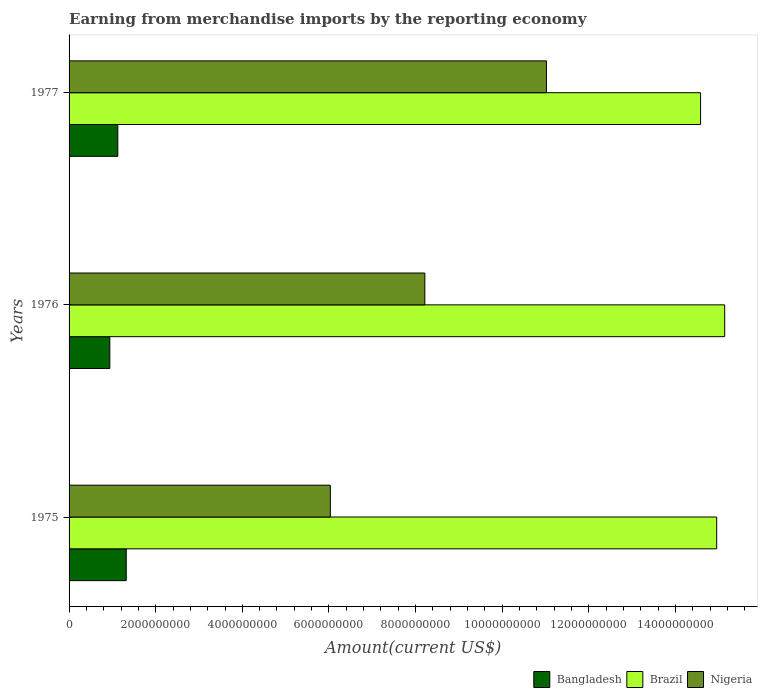How many different coloured bars are there?
Offer a very short reply. 3. Are the number of bars per tick equal to the number of legend labels?
Give a very brief answer. Yes. Are the number of bars on each tick of the Y-axis equal?
Your answer should be very brief. Yes. How many bars are there on the 1st tick from the top?
Keep it short and to the point. 3. How many bars are there on the 1st tick from the bottom?
Your answer should be very brief. 3. What is the label of the 3rd group of bars from the top?
Ensure brevity in your answer.  1975. What is the amount earned from merchandise imports in Brazil in 1977?
Make the answer very short. 1.46e+1. Across all years, what is the maximum amount earned from merchandise imports in Brazil?
Offer a very short reply. 1.51e+1. Across all years, what is the minimum amount earned from merchandise imports in Nigeria?
Offer a very short reply. 6.03e+09. In which year was the amount earned from merchandise imports in Nigeria maximum?
Provide a short and direct response. 1977. In which year was the amount earned from merchandise imports in Nigeria minimum?
Make the answer very short. 1975. What is the total amount earned from merchandise imports in Brazil in the graph?
Offer a very short reply. 4.47e+1. What is the difference between the amount earned from merchandise imports in Bangladesh in 1975 and that in 1977?
Provide a succinct answer. 1.95e+08. What is the difference between the amount earned from merchandise imports in Nigeria in 1975 and the amount earned from merchandise imports in Brazil in 1976?
Offer a very short reply. -9.10e+09. What is the average amount earned from merchandise imports in Brazil per year?
Provide a short and direct response. 1.49e+1. In the year 1977, what is the difference between the amount earned from merchandise imports in Brazil and amount earned from merchandise imports in Bangladesh?
Your response must be concise. 1.35e+1. In how many years, is the amount earned from merchandise imports in Brazil greater than 1600000000 US$?
Give a very brief answer. 3. What is the ratio of the amount earned from merchandise imports in Nigeria in 1975 to that in 1977?
Your response must be concise. 0.55. Is the amount earned from merchandise imports in Bangladesh in 1976 less than that in 1977?
Keep it short and to the point. Yes. What is the difference between the highest and the second highest amount earned from merchandise imports in Nigeria?
Provide a succinct answer. 2.81e+09. What is the difference between the highest and the lowest amount earned from merchandise imports in Nigeria?
Your answer should be compact. 4.99e+09. Is it the case that in every year, the sum of the amount earned from merchandise imports in Nigeria and amount earned from merchandise imports in Bangladesh is greater than the amount earned from merchandise imports in Brazil?
Offer a terse response. No. Are all the bars in the graph horizontal?
Give a very brief answer. Yes. Are the values on the major ticks of X-axis written in scientific E-notation?
Your answer should be compact. No. How many legend labels are there?
Offer a very short reply. 3. What is the title of the graph?
Make the answer very short. Earning from merchandise imports by the reporting economy. What is the label or title of the X-axis?
Keep it short and to the point. Amount(current US$). What is the Amount(current US$) in Bangladesh in 1975?
Give a very brief answer. 1.32e+09. What is the Amount(current US$) in Brazil in 1975?
Provide a succinct answer. 1.50e+1. What is the Amount(current US$) in Nigeria in 1975?
Your answer should be very brief. 6.03e+09. What is the Amount(current US$) in Bangladesh in 1976?
Your answer should be compact. 9.40e+08. What is the Amount(current US$) of Brazil in 1976?
Provide a succinct answer. 1.51e+1. What is the Amount(current US$) of Nigeria in 1976?
Provide a succinct answer. 8.21e+09. What is the Amount(current US$) of Bangladesh in 1977?
Give a very brief answer. 1.12e+09. What is the Amount(current US$) of Brazil in 1977?
Your answer should be very brief. 1.46e+1. What is the Amount(current US$) of Nigeria in 1977?
Ensure brevity in your answer.  1.10e+1. Across all years, what is the maximum Amount(current US$) in Bangladesh?
Provide a short and direct response. 1.32e+09. Across all years, what is the maximum Amount(current US$) of Brazil?
Provide a succinct answer. 1.51e+1. Across all years, what is the maximum Amount(current US$) of Nigeria?
Ensure brevity in your answer.  1.10e+1. Across all years, what is the minimum Amount(current US$) in Bangladesh?
Ensure brevity in your answer.  9.40e+08. Across all years, what is the minimum Amount(current US$) of Brazil?
Provide a short and direct response. 1.46e+1. Across all years, what is the minimum Amount(current US$) of Nigeria?
Provide a succinct answer. 6.03e+09. What is the total Amount(current US$) of Bangladesh in the graph?
Provide a short and direct response. 3.39e+09. What is the total Amount(current US$) of Brazil in the graph?
Your answer should be compact. 4.47e+1. What is the total Amount(current US$) in Nigeria in the graph?
Ensure brevity in your answer.  2.53e+1. What is the difference between the Amount(current US$) in Bangladesh in 1975 and that in 1976?
Your answer should be compact. 3.79e+08. What is the difference between the Amount(current US$) in Brazil in 1975 and that in 1976?
Ensure brevity in your answer.  -1.85e+08. What is the difference between the Amount(current US$) in Nigeria in 1975 and that in 1976?
Keep it short and to the point. -2.18e+09. What is the difference between the Amount(current US$) in Bangladesh in 1975 and that in 1977?
Offer a very short reply. 1.95e+08. What is the difference between the Amount(current US$) of Brazil in 1975 and that in 1977?
Give a very brief answer. 3.72e+08. What is the difference between the Amount(current US$) in Nigeria in 1975 and that in 1977?
Offer a terse response. -4.99e+09. What is the difference between the Amount(current US$) in Bangladesh in 1976 and that in 1977?
Make the answer very short. -1.84e+08. What is the difference between the Amount(current US$) of Brazil in 1976 and that in 1977?
Make the answer very short. 5.57e+08. What is the difference between the Amount(current US$) of Nigeria in 1976 and that in 1977?
Offer a very short reply. -2.81e+09. What is the difference between the Amount(current US$) of Bangladesh in 1975 and the Amount(current US$) of Brazil in 1976?
Give a very brief answer. -1.38e+1. What is the difference between the Amount(current US$) in Bangladesh in 1975 and the Amount(current US$) in Nigeria in 1976?
Provide a short and direct response. -6.89e+09. What is the difference between the Amount(current US$) in Brazil in 1975 and the Amount(current US$) in Nigeria in 1976?
Give a very brief answer. 6.74e+09. What is the difference between the Amount(current US$) in Bangladesh in 1975 and the Amount(current US$) in Brazil in 1977?
Offer a very short reply. -1.33e+1. What is the difference between the Amount(current US$) of Bangladesh in 1975 and the Amount(current US$) of Nigeria in 1977?
Offer a very short reply. -9.70e+09. What is the difference between the Amount(current US$) of Brazil in 1975 and the Amount(current US$) of Nigeria in 1977?
Make the answer very short. 3.93e+09. What is the difference between the Amount(current US$) in Bangladesh in 1976 and the Amount(current US$) in Brazil in 1977?
Make the answer very short. -1.36e+1. What is the difference between the Amount(current US$) of Bangladesh in 1976 and the Amount(current US$) of Nigeria in 1977?
Give a very brief answer. -1.01e+1. What is the difference between the Amount(current US$) of Brazil in 1976 and the Amount(current US$) of Nigeria in 1977?
Keep it short and to the point. 4.12e+09. What is the average Amount(current US$) of Bangladesh per year?
Your answer should be compact. 1.13e+09. What is the average Amount(current US$) of Brazil per year?
Your answer should be compact. 1.49e+1. What is the average Amount(current US$) in Nigeria per year?
Your response must be concise. 8.42e+09. In the year 1975, what is the difference between the Amount(current US$) in Bangladesh and Amount(current US$) in Brazil?
Your answer should be very brief. -1.36e+1. In the year 1975, what is the difference between the Amount(current US$) in Bangladesh and Amount(current US$) in Nigeria?
Offer a terse response. -4.71e+09. In the year 1975, what is the difference between the Amount(current US$) in Brazil and Amount(current US$) in Nigeria?
Offer a terse response. 8.92e+09. In the year 1976, what is the difference between the Amount(current US$) in Bangladesh and Amount(current US$) in Brazil?
Ensure brevity in your answer.  -1.42e+1. In the year 1976, what is the difference between the Amount(current US$) in Bangladesh and Amount(current US$) in Nigeria?
Provide a succinct answer. -7.27e+09. In the year 1976, what is the difference between the Amount(current US$) in Brazil and Amount(current US$) in Nigeria?
Provide a succinct answer. 6.92e+09. In the year 1977, what is the difference between the Amount(current US$) in Bangladesh and Amount(current US$) in Brazil?
Your response must be concise. -1.35e+1. In the year 1977, what is the difference between the Amount(current US$) in Bangladesh and Amount(current US$) in Nigeria?
Offer a very short reply. -9.90e+09. In the year 1977, what is the difference between the Amount(current US$) of Brazil and Amount(current US$) of Nigeria?
Make the answer very short. 3.56e+09. What is the ratio of the Amount(current US$) of Bangladesh in 1975 to that in 1976?
Provide a succinct answer. 1.4. What is the ratio of the Amount(current US$) of Nigeria in 1975 to that in 1976?
Your answer should be compact. 0.73. What is the ratio of the Amount(current US$) in Bangladesh in 1975 to that in 1977?
Provide a short and direct response. 1.17. What is the ratio of the Amount(current US$) in Brazil in 1975 to that in 1977?
Provide a short and direct response. 1.03. What is the ratio of the Amount(current US$) of Nigeria in 1975 to that in 1977?
Offer a very short reply. 0.55. What is the ratio of the Amount(current US$) of Bangladesh in 1976 to that in 1977?
Ensure brevity in your answer.  0.84. What is the ratio of the Amount(current US$) in Brazil in 1976 to that in 1977?
Your answer should be very brief. 1.04. What is the ratio of the Amount(current US$) in Nigeria in 1976 to that in 1977?
Provide a succinct answer. 0.75. What is the difference between the highest and the second highest Amount(current US$) of Bangladesh?
Your response must be concise. 1.95e+08. What is the difference between the highest and the second highest Amount(current US$) of Brazil?
Keep it short and to the point. 1.85e+08. What is the difference between the highest and the second highest Amount(current US$) of Nigeria?
Ensure brevity in your answer.  2.81e+09. What is the difference between the highest and the lowest Amount(current US$) in Bangladesh?
Give a very brief answer. 3.79e+08. What is the difference between the highest and the lowest Amount(current US$) in Brazil?
Offer a terse response. 5.57e+08. What is the difference between the highest and the lowest Amount(current US$) of Nigeria?
Provide a short and direct response. 4.99e+09. 